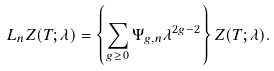<formula> <loc_0><loc_0><loc_500><loc_500>L _ { n } Z ( T ; \lambda ) = \left \{ \sum _ { g \geq 0 } \Psi _ { g , n } \lambda ^ { 2 g - 2 } \right \} Z ( T ; \lambda ) .</formula> 